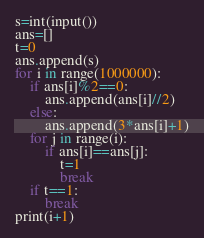<code> <loc_0><loc_0><loc_500><loc_500><_Python_>s=int(input())
ans=[]
t=0
ans.append(s)
for i in range(1000000):
    if ans[i]%2==0:
        ans.append(ans[i]//2)
    else:
        ans.append(3*ans[i]+1)
    for j in range(i):
        if ans[i]==ans[j]:
            t=1
            break
    if t==1:
        break
print(i+1)</code> 